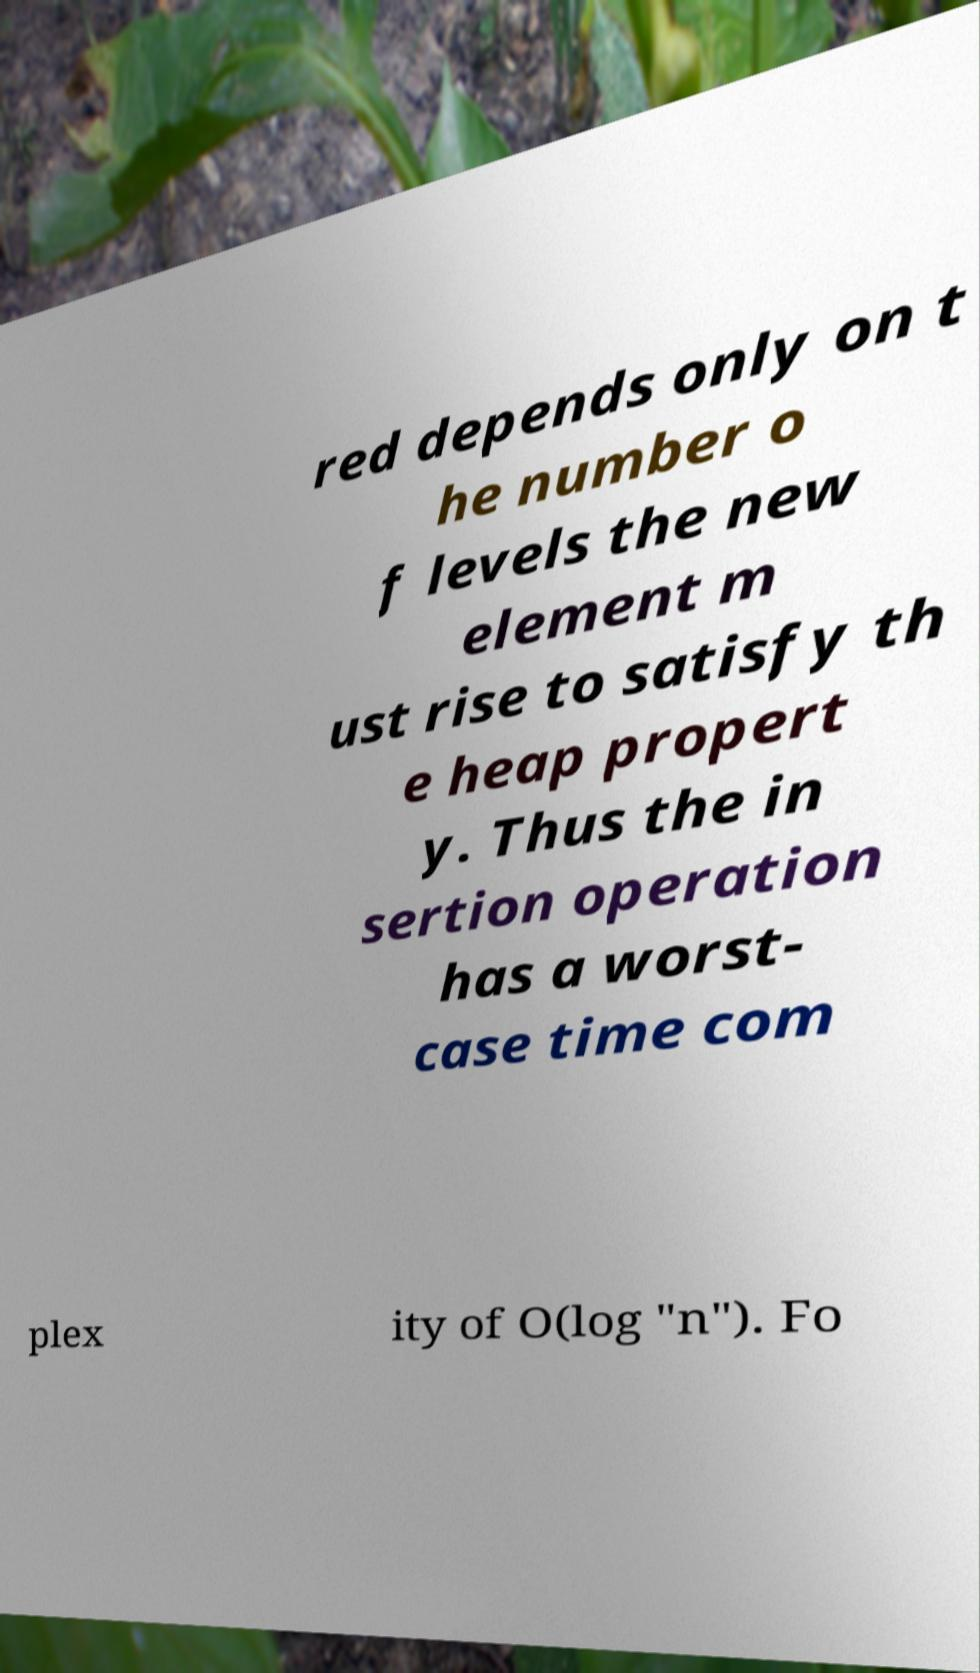Could you extract and type out the text from this image? red depends only on t he number o f levels the new element m ust rise to satisfy th e heap propert y. Thus the in sertion operation has a worst- case time com plex ity of O(log "n"). Fo 